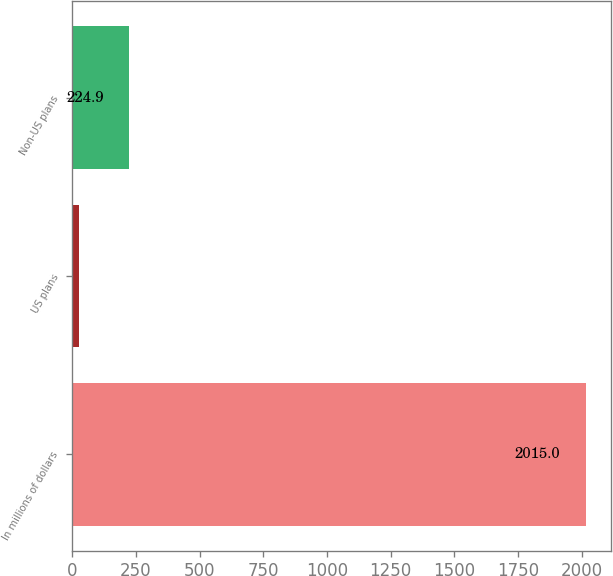Convert chart to OTSL. <chart><loc_0><loc_0><loc_500><loc_500><bar_chart><fcel>In millions of dollars<fcel>US plans<fcel>Non-US plans<nl><fcel>2015<fcel>26<fcel>224.9<nl></chart> 